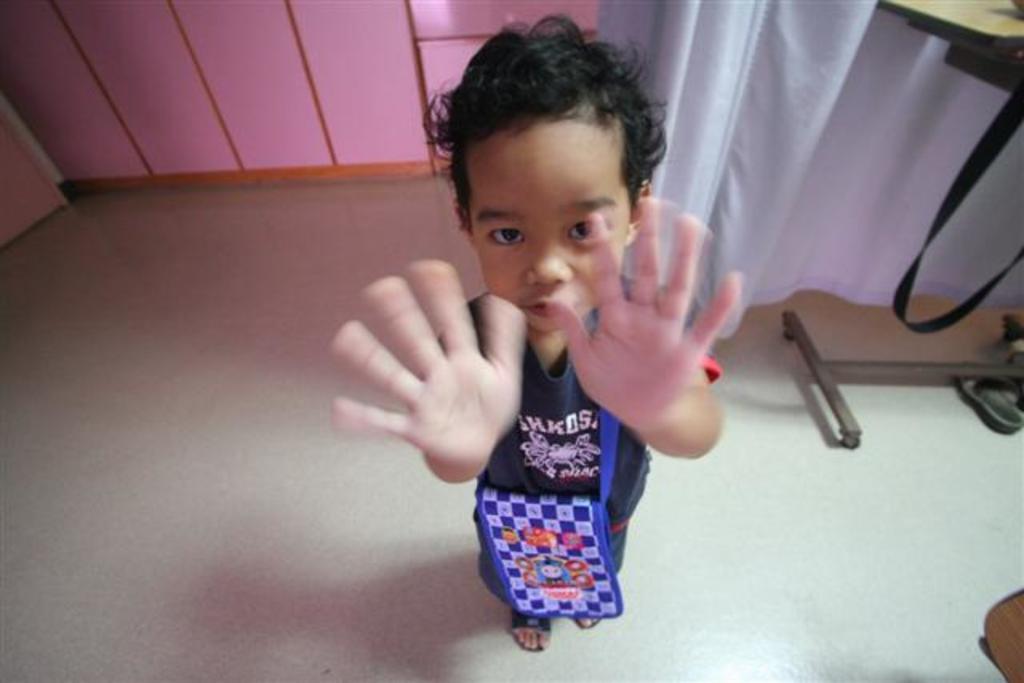What is the main subject in the middle of the image? There is a kid in the middle of the image. What can be seen on the right side of the image? There is a curtain on the right side of the image. Where is the faucet located in the image? There is no faucet present in the image. What type of connection can be seen between the kid and the curtain? There is no connection between the kid and the curtain in the image. 